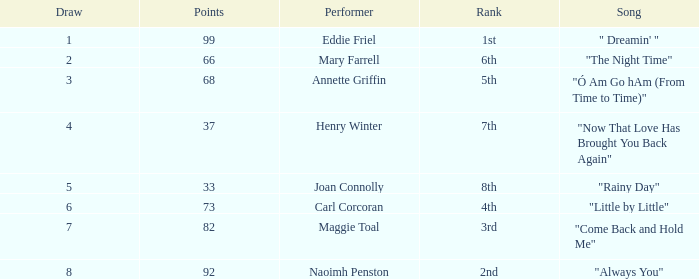What is the lowest points when the ranking is 1st? 99.0. 